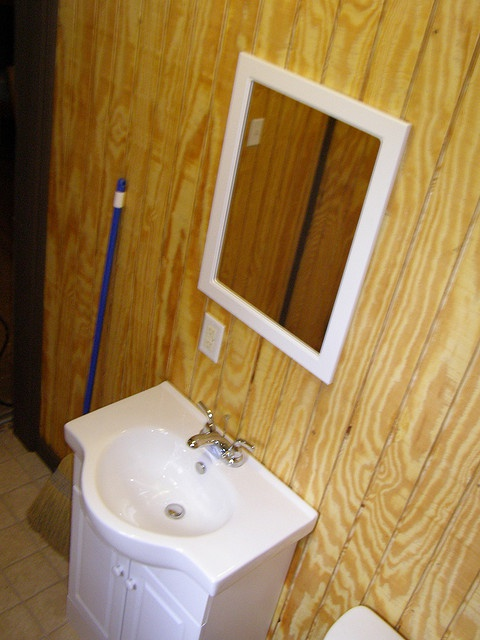Describe the objects in this image and their specific colors. I can see a sink in black, lightgray, tan, and darkgray tones in this image. 